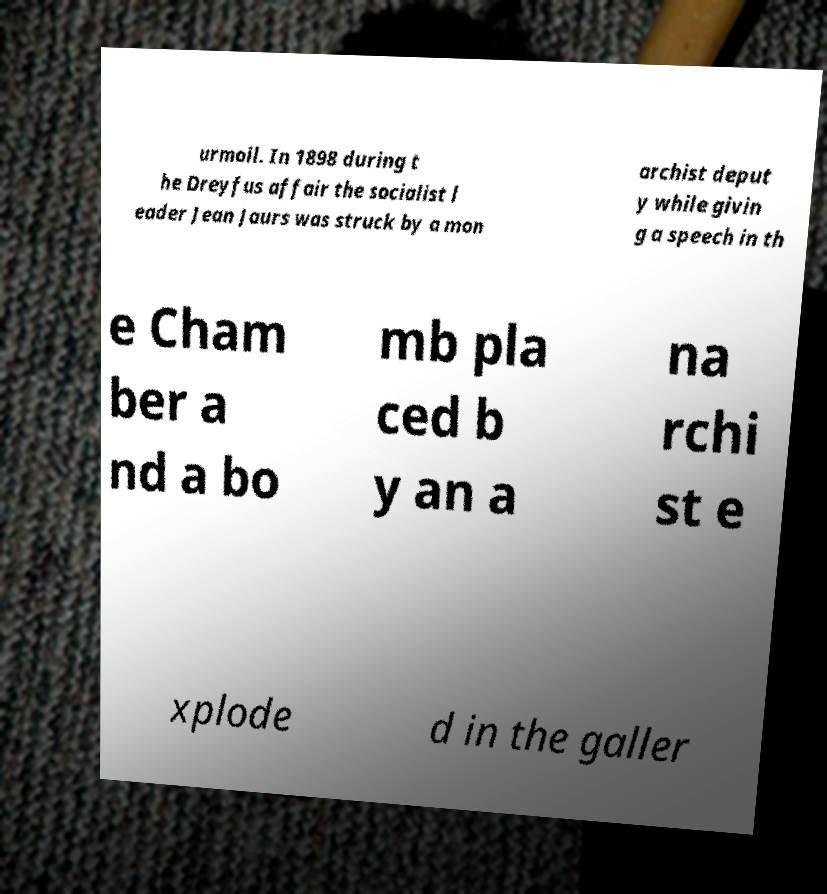Please identify and transcribe the text found in this image. urmoil. In 1898 during t he Dreyfus affair the socialist l eader Jean Jaurs was struck by a mon archist deput y while givin g a speech in th e Cham ber a nd a bo mb pla ced b y an a na rchi st e xplode d in the galler 